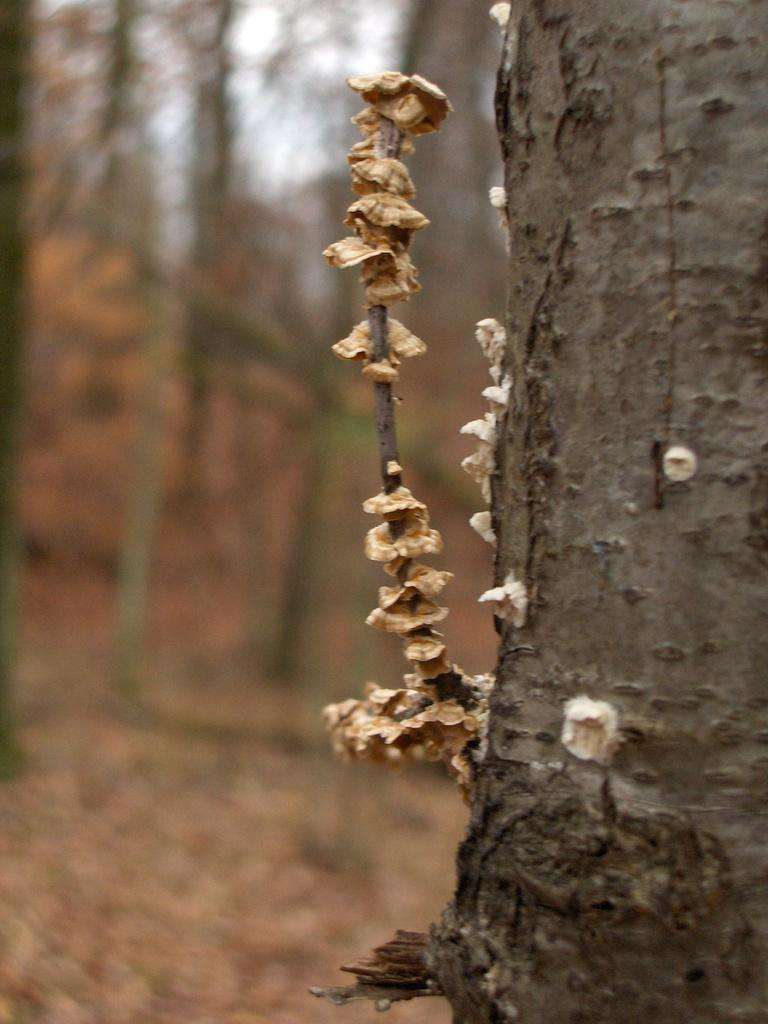What type of vegetation can be seen in the front of the image? There are fungi mushrooms in the front of the image. What type of natural environment is visible in the background of the image? There are trees in the background of the image. How would you describe the appearance of the background? The background appears blurry. What type of instrument is being played by the kitty in the image? There is no kitty or instrument present in the image. 